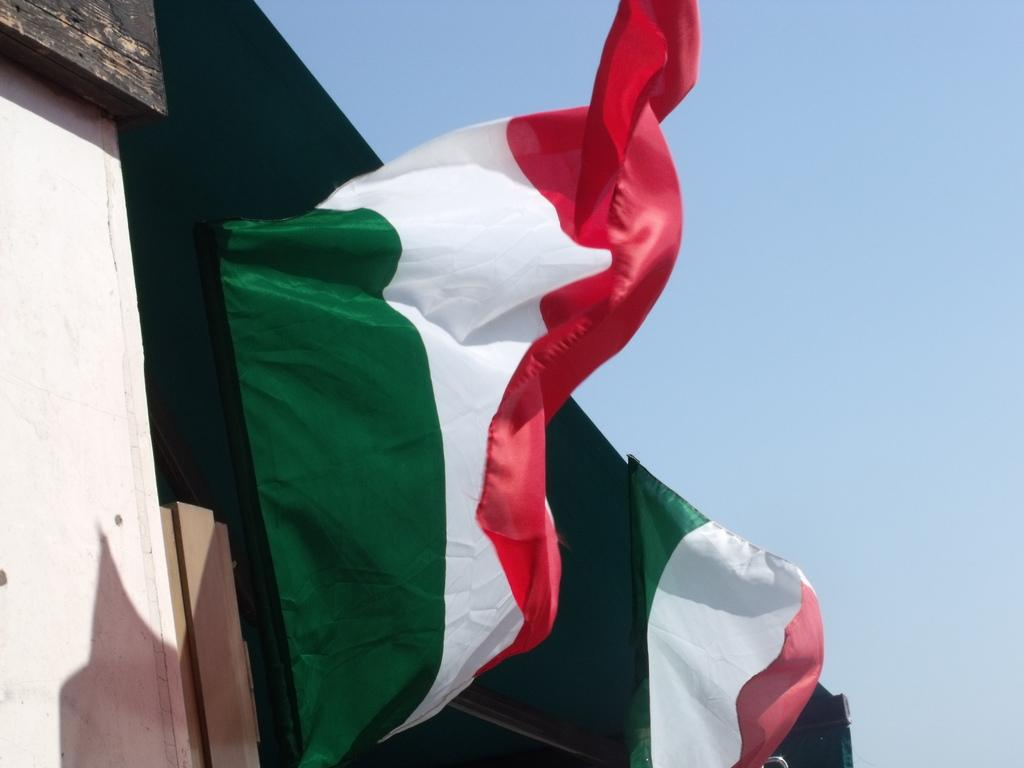What is present in the image that represents a symbol or country? There is a flag in the image. What colors are present on the flag? The flag has green, white, and red colors. What can be seen in the background of the image? The sky is visible in the background of the image. What is the color of the sky in the image? The sky is blue in color. Are there any fowl resting on the stage in the image? There is no stage or fowl present in the image. What type of rest can be seen in the image? There is no rest or resting activity depicted in the image. 